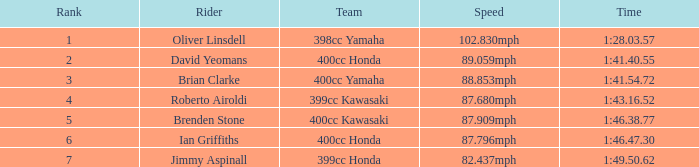Who is the rider with a 399cc Kawasaki? Roberto Airoldi. 